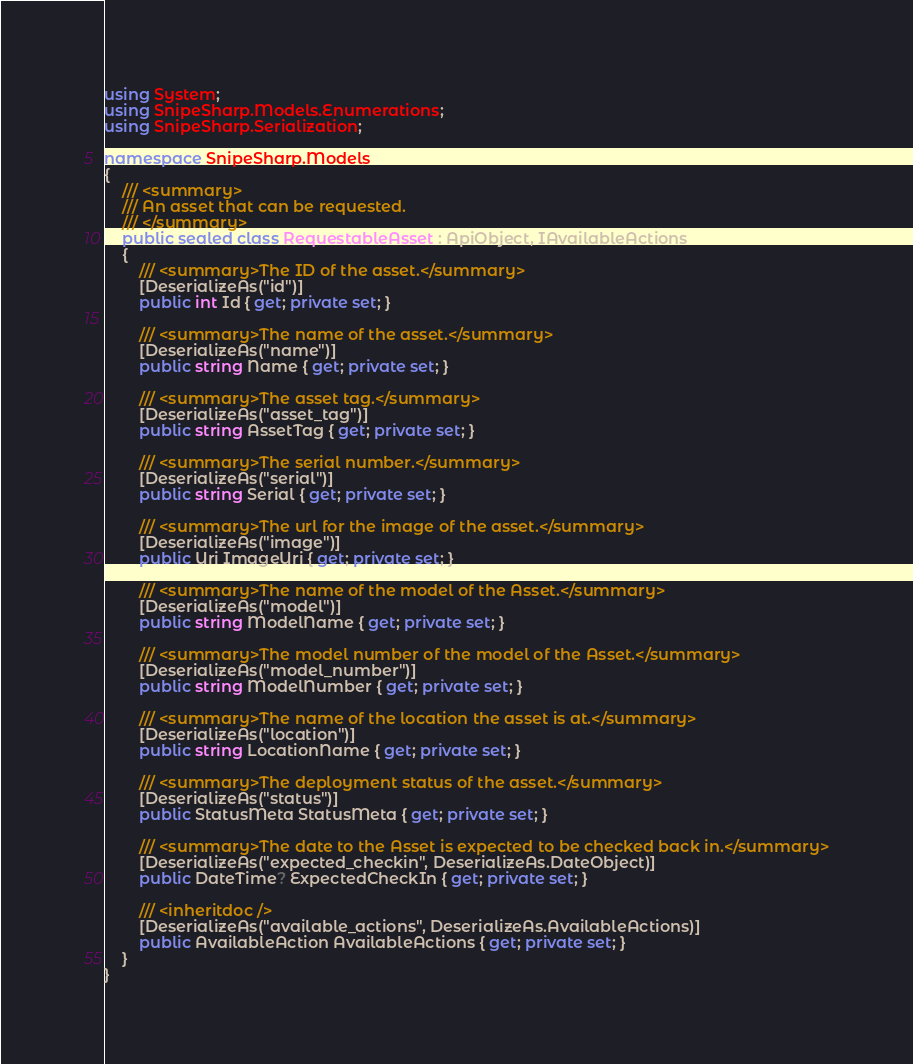Convert code to text. <code><loc_0><loc_0><loc_500><loc_500><_C#_>using System;
using SnipeSharp.Models.Enumerations;
using SnipeSharp.Serialization;

namespace SnipeSharp.Models
{
    /// <summary>
    /// An asset that can be requested.
    /// </summary>
    public sealed class RequestableAsset : ApiObject, IAvailableActions
    {
        /// <summary>The ID of the asset.</summary>
        [DeserializeAs("id")]
        public int Id { get; private set; }

        /// <summary>The name of the asset.</summary>
        [DeserializeAs("name")]
        public string Name { get; private set; }

        /// <summary>The asset tag.</summary>
        [DeserializeAs("asset_tag")]
        public string AssetTag { get; private set; }

        /// <summary>The serial number.</summary>
        [DeserializeAs("serial")]
        public string Serial { get; private set; }

        /// <summary>The url for the image of the asset.</summary>
        [DeserializeAs("image")]
        public Uri ImageUri { get; private set; }

        /// <summary>The name of the model of the Asset.</summary>
        [DeserializeAs("model")]
        public string ModelName { get; private set; }

        /// <summary>The model number of the model of the Asset.</summary>
        [DeserializeAs("model_number")]
        public string ModelNumber { get; private set; }

        /// <summary>The name of the location the asset is at.</summary>
        [DeserializeAs("location")]
        public string LocationName { get; private set; }

        /// <summary>The deployment status of the asset.</summary>
        [DeserializeAs("status")]
        public StatusMeta StatusMeta { get; private set; }

        /// <summary>The date to the Asset is expected to be checked back in.</summary>
        [DeserializeAs("expected_checkin", DeserializeAs.DateObject)]
        public DateTime? ExpectedCheckIn { get; private set; }

        /// <inheritdoc />
        [DeserializeAs("available_actions", DeserializeAs.AvailableActions)]
        public AvailableAction AvailableActions { get; private set; }
    }
}
</code> 